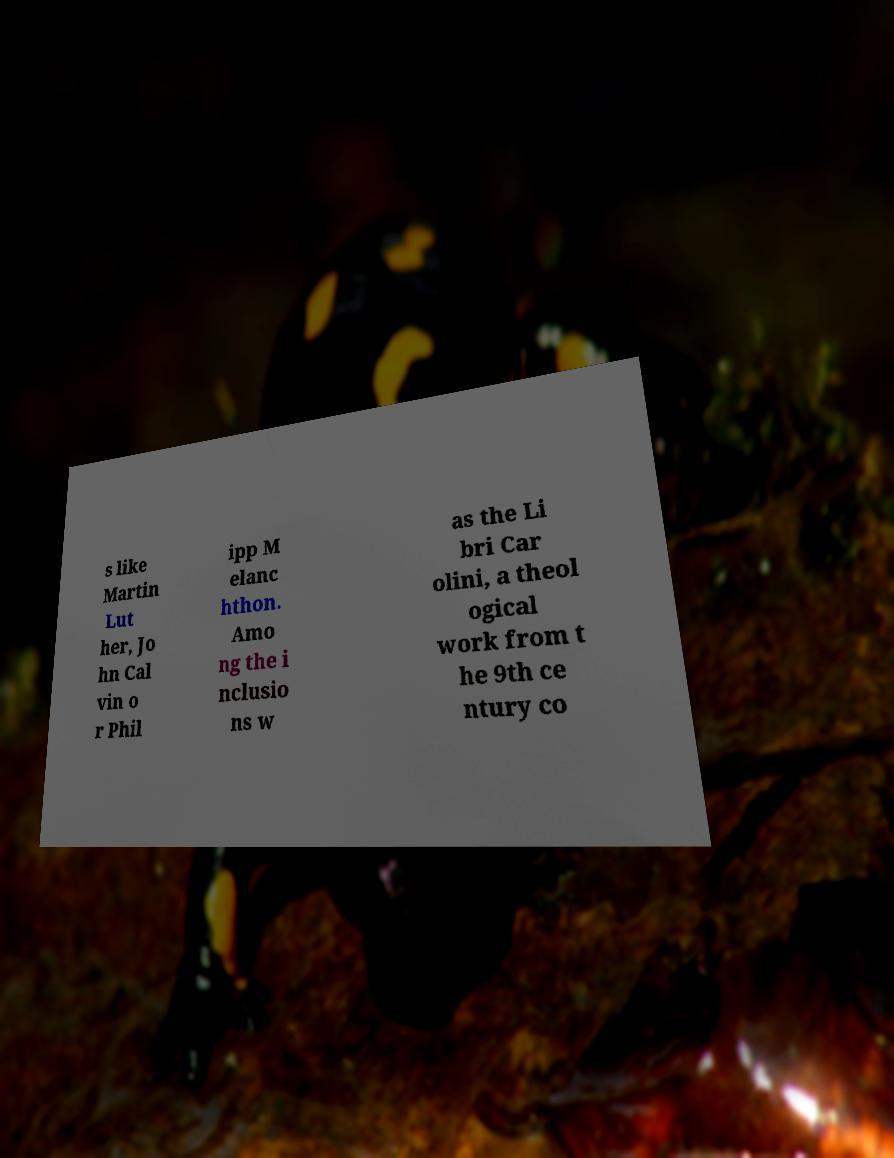Can you read and provide the text displayed in the image?This photo seems to have some interesting text. Can you extract and type it out for me? s like Martin Lut her, Jo hn Cal vin o r Phil ipp M elanc hthon. Amo ng the i nclusio ns w as the Li bri Car olini, a theol ogical work from t he 9th ce ntury co 